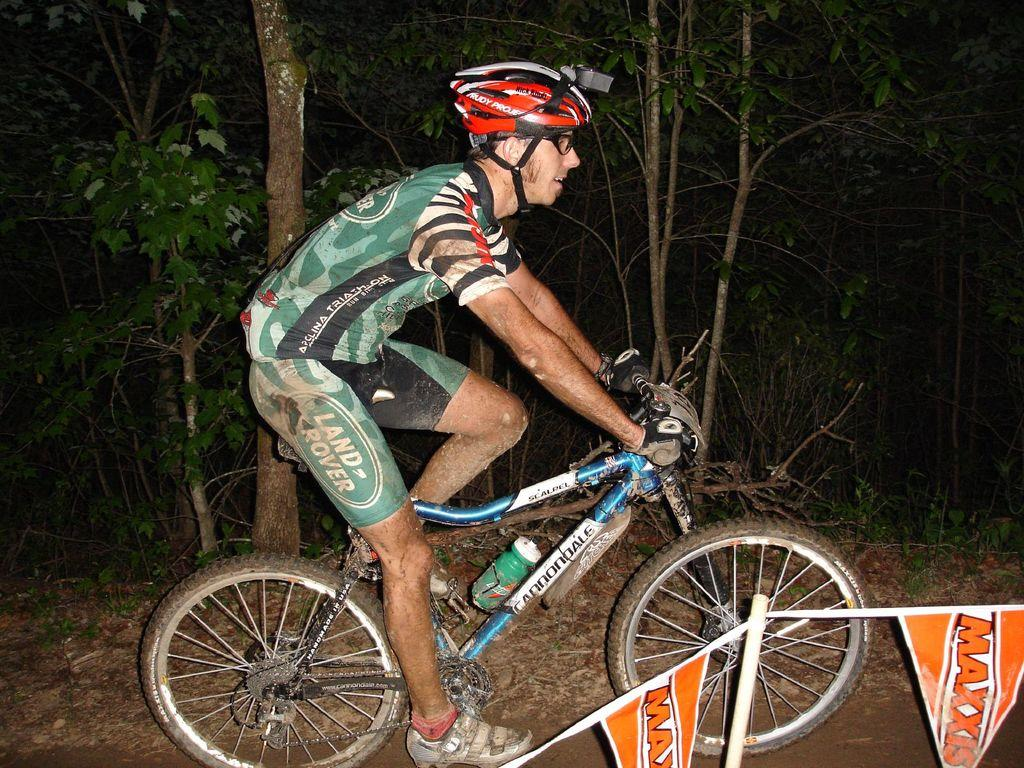What is the person in the image doing? The person is sitting on a bicycle in the image. What can be seen in the background of the image? There are trees visible in the image. What is the surface on which the bicycle is riding? The ground is visible in the image. What additional objects are present in the image? There are flags in the image. What invention is the person using to travel on the ground in the image? The person is not using an invention to travel on the ground; they are sitting on a bicycle, which is a well-established mode of transportation. 